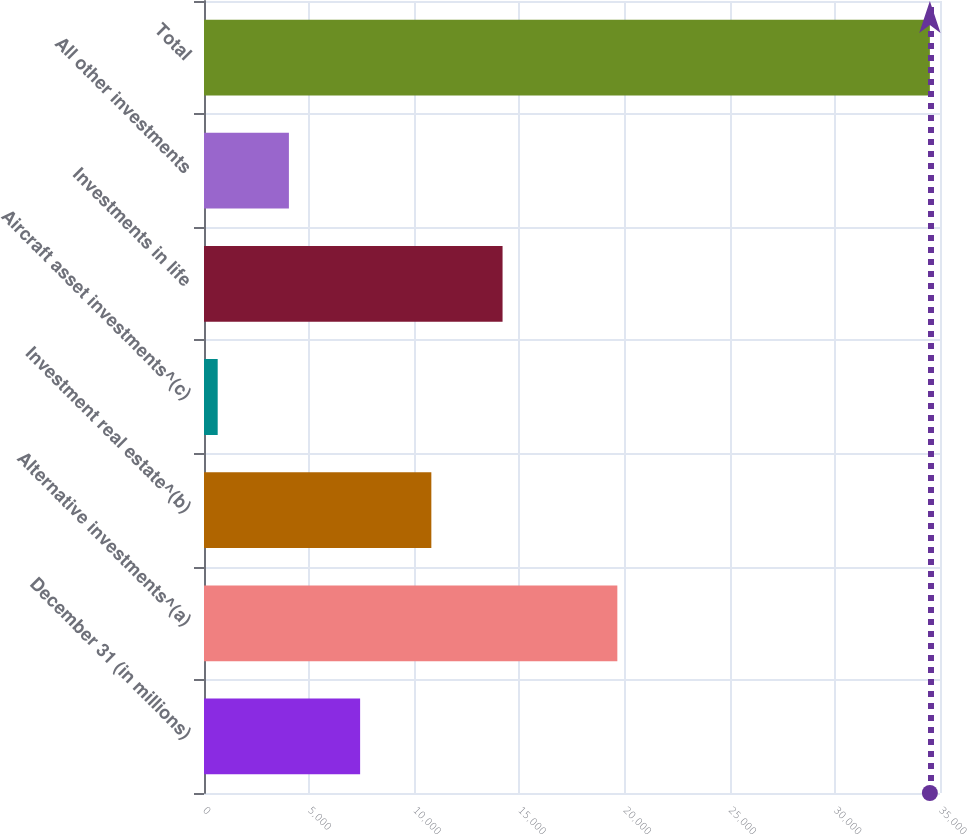Convert chart. <chart><loc_0><loc_0><loc_500><loc_500><bar_chart><fcel>December 31 (in millions)<fcel>Alternative investments^(a)<fcel>Investment real estate^(b)<fcel>Aircraft asset investments^(c)<fcel>Investments in life<fcel>All other investments<fcel>Total<nl><fcel>7424.4<fcel>19656<fcel>10811.1<fcel>651<fcel>14197.8<fcel>4037.7<fcel>34518<nl></chart> 